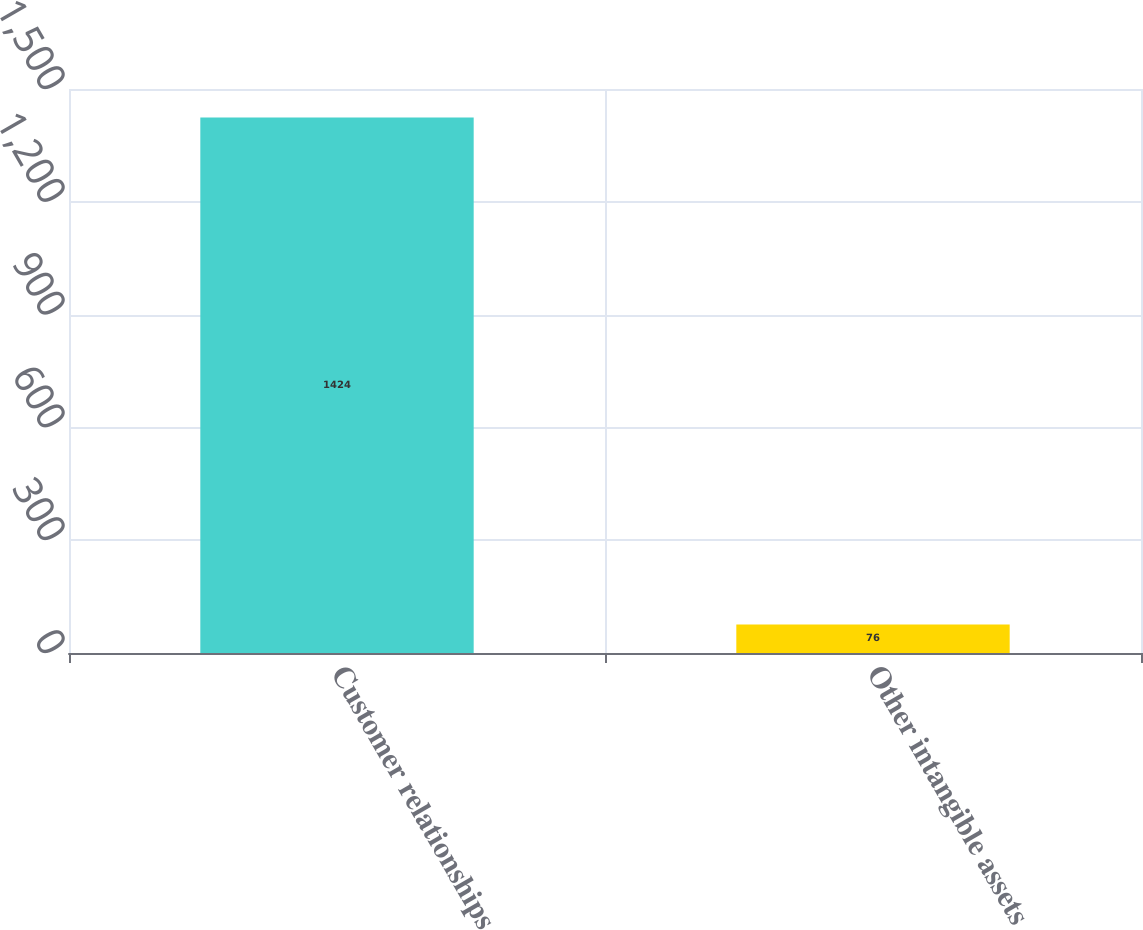Convert chart. <chart><loc_0><loc_0><loc_500><loc_500><bar_chart><fcel>Customer relationships<fcel>Other intangible assets<nl><fcel>1424<fcel>76<nl></chart> 